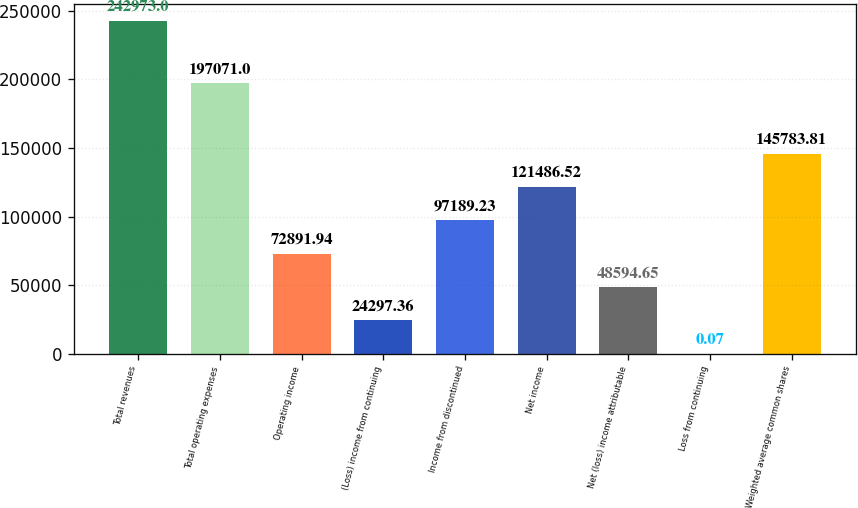Convert chart. <chart><loc_0><loc_0><loc_500><loc_500><bar_chart><fcel>Total revenues<fcel>Total operating expenses<fcel>Operating income<fcel>(Loss) income from continuing<fcel>Income from discontinued<fcel>Net income<fcel>Net (loss) income attributable<fcel>Loss from continuing<fcel>Weighted average common shares<nl><fcel>242973<fcel>197071<fcel>72891.9<fcel>24297.4<fcel>97189.2<fcel>121487<fcel>48594.7<fcel>0.07<fcel>145784<nl></chart> 